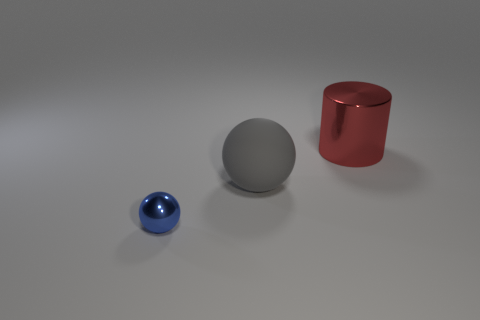Is there any other thing that is the same size as the blue object?
Ensure brevity in your answer.  No. The metal ball is what size?
Your response must be concise. Small. Do the big cylinder and the metallic sphere have the same color?
Give a very brief answer. No. How many things are purple matte cylinders or red metallic cylinders that are to the right of the metallic ball?
Your answer should be very brief. 1. There is a metal thing behind the metal object that is on the left side of the big cylinder; how many tiny blue balls are to the right of it?
Make the answer very short. 0. How many big metallic cylinders are there?
Keep it short and to the point. 1. There is a metallic thing behind the blue metal object; does it have the same size as the matte sphere?
Offer a very short reply. Yes. How many matte objects are small cylinders or big things?
Ensure brevity in your answer.  1. What number of small metallic things are in front of the sphere that is to the right of the blue metal thing?
Offer a terse response. 1. There is a object that is both to the left of the red metal thing and behind the tiny thing; what is its shape?
Offer a very short reply. Sphere. 